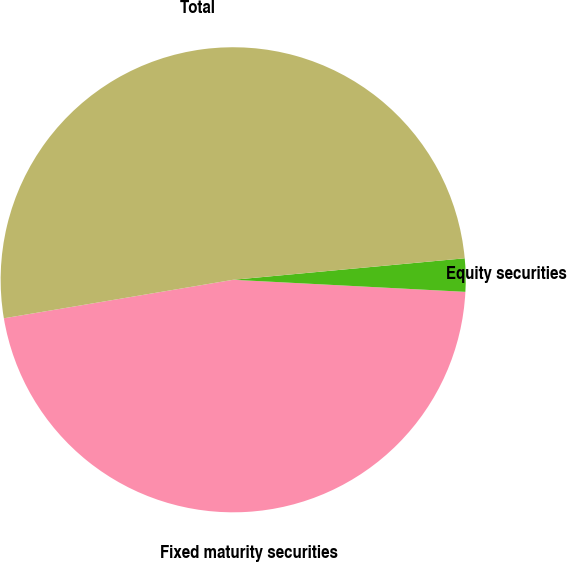<chart> <loc_0><loc_0><loc_500><loc_500><pie_chart><fcel>Fixed maturity securities<fcel>Equity securities<fcel>Total<nl><fcel>46.53%<fcel>2.3%<fcel>51.18%<nl></chart> 